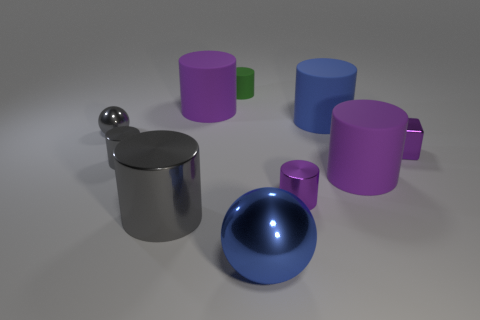Subtract all small purple metallic cylinders. How many cylinders are left? 6 Subtract all gray cylinders. How many cylinders are left? 5 Subtract 6 cylinders. How many cylinders are left? 1 Add 4 green metallic blocks. How many green metallic blocks exist? 4 Subtract 0 red balls. How many objects are left? 10 Subtract all cubes. How many objects are left? 9 Subtract all red balls. Subtract all brown cylinders. How many balls are left? 2 Subtract all cyan cylinders. How many brown spheres are left? 0 Subtract all big blue matte cylinders. Subtract all green objects. How many objects are left? 8 Add 1 matte objects. How many matte objects are left? 5 